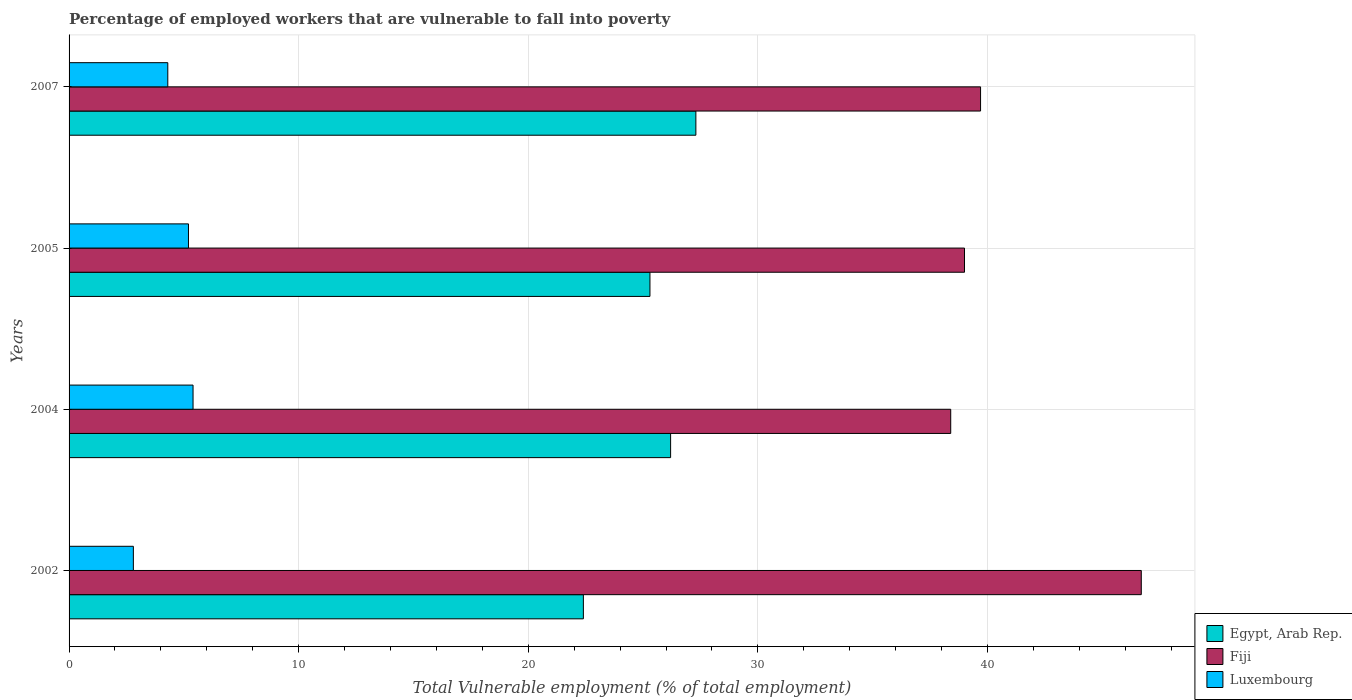How many different coloured bars are there?
Your response must be concise. 3. How many groups of bars are there?
Your answer should be very brief. 4. What is the label of the 2nd group of bars from the top?
Make the answer very short. 2005. In how many cases, is the number of bars for a given year not equal to the number of legend labels?
Ensure brevity in your answer.  0. What is the percentage of employed workers who are vulnerable to fall into poverty in Egypt, Arab Rep. in 2005?
Provide a short and direct response. 25.3. Across all years, what is the maximum percentage of employed workers who are vulnerable to fall into poverty in Fiji?
Offer a very short reply. 46.7. Across all years, what is the minimum percentage of employed workers who are vulnerable to fall into poverty in Luxembourg?
Provide a short and direct response. 2.8. What is the total percentage of employed workers who are vulnerable to fall into poverty in Luxembourg in the graph?
Your response must be concise. 17.7. What is the difference between the percentage of employed workers who are vulnerable to fall into poverty in Egypt, Arab Rep. in 2004 and that in 2005?
Offer a very short reply. 0.9. What is the difference between the percentage of employed workers who are vulnerable to fall into poverty in Egypt, Arab Rep. in 2007 and the percentage of employed workers who are vulnerable to fall into poverty in Luxembourg in 2002?
Your response must be concise. 24.5. What is the average percentage of employed workers who are vulnerable to fall into poverty in Luxembourg per year?
Provide a short and direct response. 4.43. In the year 2004, what is the difference between the percentage of employed workers who are vulnerable to fall into poverty in Egypt, Arab Rep. and percentage of employed workers who are vulnerable to fall into poverty in Luxembourg?
Your answer should be compact. 20.8. In how many years, is the percentage of employed workers who are vulnerable to fall into poverty in Fiji greater than 26 %?
Offer a very short reply. 4. What is the ratio of the percentage of employed workers who are vulnerable to fall into poverty in Fiji in 2002 to that in 2007?
Give a very brief answer. 1.18. Is the difference between the percentage of employed workers who are vulnerable to fall into poverty in Egypt, Arab Rep. in 2002 and 2004 greater than the difference between the percentage of employed workers who are vulnerable to fall into poverty in Luxembourg in 2002 and 2004?
Make the answer very short. No. What is the difference between the highest and the second highest percentage of employed workers who are vulnerable to fall into poverty in Luxembourg?
Your answer should be very brief. 0.2. What is the difference between the highest and the lowest percentage of employed workers who are vulnerable to fall into poverty in Luxembourg?
Offer a terse response. 2.6. In how many years, is the percentage of employed workers who are vulnerable to fall into poverty in Fiji greater than the average percentage of employed workers who are vulnerable to fall into poverty in Fiji taken over all years?
Make the answer very short. 1. What does the 1st bar from the top in 2002 represents?
Your response must be concise. Luxembourg. What does the 1st bar from the bottom in 2004 represents?
Provide a short and direct response. Egypt, Arab Rep. Is it the case that in every year, the sum of the percentage of employed workers who are vulnerable to fall into poverty in Luxembourg and percentage of employed workers who are vulnerable to fall into poverty in Fiji is greater than the percentage of employed workers who are vulnerable to fall into poverty in Egypt, Arab Rep.?
Provide a succinct answer. Yes. Are all the bars in the graph horizontal?
Your response must be concise. Yes. How many years are there in the graph?
Offer a very short reply. 4. What is the difference between two consecutive major ticks on the X-axis?
Offer a very short reply. 10. Does the graph contain grids?
Your response must be concise. Yes. How many legend labels are there?
Ensure brevity in your answer.  3. How are the legend labels stacked?
Make the answer very short. Vertical. What is the title of the graph?
Your response must be concise. Percentage of employed workers that are vulnerable to fall into poverty. What is the label or title of the X-axis?
Offer a terse response. Total Vulnerable employment (% of total employment). What is the Total Vulnerable employment (% of total employment) in Egypt, Arab Rep. in 2002?
Give a very brief answer. 22.4. What is the Total Vulnerable employment (% of total employment) of Fiji in 2002?
Offer a terse response. 46.7. What is the Total Vulnerable employment (% of total employment) of Luxembourg in 2002?
Your response must be concise. 2.8. What is the Total Vulnerable employment (% of total employment) of Egypt, Arab Rep. in 2004?
Keep it short and to the point. 26.2. What is the Total Vulnerable employment (% of total employment) in Fiji in 2004?
Make the answer very short. 38.4. What is the Total Vulnerable employment (% of total employment) of Luxembourg in 2004?
Give a very brief answer. 5.4. What is the Total Vulnerable employment (% of total employment) of Egypt, Arab Rep. in 2005?
Provide a succinct answer. 25.3. What is the Total Vulnerable employment (% of total employment) of Fiji in 2005?
Keep it short and to the point. 39. What is the Total Vulnerable employment (% of total employment) in Luxembourg in 2005?
Your answer should be compact. 5.2. What is the Total Vulnerable employment (% of total employment) of Egypt, Arab Rep. in 2007?
Provide a succinct answer. 27.3. What is the Total Vulnerable employment (% of total employment) of Fiji in 2007?
Keep it short and to the point. 39.7. What is the Total Vulnerable employment (% of total employment) in Luxembourg in 2007?
Ensure brevity in your answer.  4.3. Across all years, what is the maximum Total Vulnerable employment (% of total employment) in Egypt, Arab Rep.?
Give a very brief answer. 27.3. Across all years, what is the maximum Total Vulnerable employment (% of total employment) in Fiji?
Provide a short and direct response. 46.7. Across all years, what is the maximum Total Vulnerable employment (% of total employment) of Luxembourg?
Keep it short and to the point. 5.4. Across all years, what is the minimum Total Vulnerable employment (% of total employment) of Egypt, Arab Rep.?
Offer a terse response. 22.4. Across all years, what is the minimum Total Vulnerable employment (% of total employment) in Fiji?
Your answer should be very brief. 38.4. Across all years, what is the minimum Total Vulnerable employment (% of total employment) of Luxembourg?
Give a very brief answer. 2.8. What is the total Total Vulnerable employment (% of total employment) in Egypt, Arab Rep. in the graph?
Your answer should be very brief. 101.2. What is the total Total Vulnerable employment (% of total employment) in Fiji in the graph?
Your answer should be compact. 163.8. What is the total Total Vulnerable employment (% of total employment) of Luxembourg in the graph?
Keep it short and to the point. 17.7. What is the difference between the Total Vulnerable employment (% of total employment) of Egypt, Arab Rep. in 2002 and that in 2007?
Offer a very short reply. -4.9. What is the difference between the Total Vulnerable employment (% of total employment) of Fiji in 2004 and that in 2005?
Your response must be concise. -0.6. What is the difference between the Total Vulnerable employment (% of total employment) in Luxembourg in 2004 and that in 2005?
Provide a short and direct response. 0.2. What is the difference between the Total Vulnerable employment (% of total employment) in Egypt, Arab Rep. in 2004 and that in 2007?
Keep it short and to the point. -1.1. What is the difference between the Total Vulnerable employment (% of total employment) of Fiji in 2004 and that in 2007?
Your response must be concise. -1.3. What is the difference between the Total Vulnerable employment (% of total employment) of Egypt, Arab Rep. in 2002 and the Total Vulnerable employment (% of total employment) of Luxembourg in 2004?
Offer a very short reply. 17. What is the difference between the Total Vulnerable employment (% of total employment) of Fiji in 2002 and the Total Vulnerable employment (% of total employment) of Luxembourg in 2004?
Make the answer very short. 41.3. What is the difference between the Total Vulnerable employment (% of total employment) in Egypt, Arab Rep. in 2002 and the Total Vulnerable employment (% of total employment) in Fiji in 2005?
Your answer should be very brief. -16.6. What is the difference between the Total Vulnerable employment (% of total employment) of Fiji in 2002 and the Total Vulnerable employment (% of total employment) of Luxembourg in 2005?
Make the answer very short. 41.5. What is the difference between the Total Vulnerable employment (% of total employment) of Egypt, Arab Rep. in 2002 and the Total Vulnerable employment (% of total employment) of Fiji in 2007?
Offer a terse response. -17.3. What is the difference between the Total Vulnerable employment (% of total employment) in Egypt, Arab Rep. in 2002 and the Total Vulnerable employment (% of total employment) in Luxembourg in 2007?
Your response must be concise. 18.1. What is the difference between the Total Vulnerable employment (% of total employment) in Fiji in 2002 and the Total Vulnerable employment (% of total employment) in Luxembourg in 2007?
Your answer should be compact. 42.4. What is the difference between the Total Vulnerable employment (% of total employment) of Fiji in 2004 and the Total Vulnerable employment (% of total employment) of Luxembourg in 2005?
Offer a very short reply. 33.2. What is the difference between the Total Vulnerable employment (% of total employment) in Egypt, Arab Rep. in 2004 and the Total Vulnerable employment (% of total employment) in Fiji in 2007?
Keep it short and to the point. -13.5. What is the difference between the Total Vulnerable employment (% of total employment) in Egypt, Arab Rep. in 2004 and the Total Vulnerable employment (% of total employment) in Luxembourg in 2007?
Give a very brief answer. 21.9. What is the difference between the Total Vulnerable employment (% of total employment) in Fiji in 2004 and the Total Vulnerable employment (% of total employment) in Luxembourg in 2007?
Provide a succinct answer. 34.1. What is the difference between the Total Vulnerable employment (% of total employment) of Egypt, Arab Rep. in 2005 and the Total Vulnerable employment (% of total employment) of Fiji in 2007?
Keep it short and to the point. -14.4. What is the difference between the Total Vulnerable employment (% of total employment) in Egypt, Arab Rep. in 2005 and the Total Vulnerable employment (% of total employment) in Luxembourg in 2007?
Make the answer very short. 21. What is the difference between the Total Vulnerable employment (% of total employment) in Fiji in 2005 and the Total Vulnerable employment (% of total employment) in Luxembourg in 2007?
Your response must be concise. 34.7. What is the average Total Vulnerable employment (% of total employment) in Egypt, Arab Rep. per year?
Your response must be concise. 25.3. What is the average Total Vulnerable employment (% of total employment) in Fiji per year?
Offer a very short reply. 40.95. What is the average Total Vulnerable employment (% of total employment) of Luxembourg per year?
Keep it short and to the point. 4.42. In the year 2002, what is the difference between the Total Vulnerable employment (% of total employment) of Egypt, Arab Rep. and Total Vulnerable employment (% of total employment) of Fiji?
Provide a short and direct response. -24.3. In the year 2002, what is the difference between the Total Vulnerable employment (% of total employment) in Egypt, Arab Rep. and Total Vulnerable employment (% of total employment) in Luxembourg?
Your response must be concise. 19.6. In the year 2002, what is the difference between the Total Vulnerable employment (% of total employment) of Fiji and Total Vulnerable employment (% of total employment) of Luxembourg?
Make the answer very short. 43.9. In the year 2004, what is the difference between the Total Vulnerable employment (% of total employment) of Egypt, Arab Rep. and Total Vulnerable employment (% of total employment) of Luxembourg?
Your response must be concise. 20.8. In the year 2004, what is the difference between the Total Vulnerable employment (% of total employment) of Fiji and Total Vulnerable employment (% of total employment) of Luxembourg?
Make the answer very short. 33. In the year 2005, what is the difference between the Total Vulnerable employment (% of total employment) in Egypt, Arab Rep. and Total Vulnerable employment (% of total employment) in Fiji?
Your answer should be compact. -13.7. In the year 2005, what is the difference between the Total Vulnerable employment (% of total employment) of Egypt, Arab Rep. and Total Vulnerable employment (% of total employment) of Luxembourg?
Offer a very short reply. 20.1. In the year 2005, what is the difference between the Total Vulnerable employment (% of total employment) of Fiji and Total Vulnerable employment (% of total employment) of Luxembourg?
Give a very brief answer. 33.8. In the year 2007, what is the difference between the Total Vulnerable employment (% of total employment) of Egypt, Arab Rep. and Total Vulnerable employment (% of total employment) of Fiji?
Offer a terse response. -12.4. In the year 2007, what is the difference between the Total Vulnerable employment (% of total employment) of Egypt, Arab Rep. and Total Vulnerable employment (% of total employment) of Luxembourg?
Provide a succinct answer. 23. In the year 2007, what is the difference between the Total Vulnerable employment (% of total employment) in Fiji and Total Vulnerable employment (% of total employment) in Luxembourg?
Offer a terse response. 35.4. What is the ratio of the Total Vulnerable employment (% of total employment) of Egypt, Arab Rep. in 2002 to that in 2004?
Your response must be concise. 0.85. What is the ratio of the Total Vulnerable employment (% of total employment) in Fiji in 2002 to that in 2004?
Your answer should be very brief. 1.22. What is the ratio of the Total Vulnerable employment (% of total employment) of Luxembourg in 2002 to that in 2004?
Give a very brief answer. 0.52. What is the ratio of the Total Vulnerable employment (% of total employment) in Egypt, Arab Rep. in 2002 to that in 2005?
Offer a terse response. 0.89. What is the ratio of the Total Vulnerable employment (% of total employment) of Fiji in 2002 to that in 2005?
Give a very brief answer. 1.2. What is the ratio of the Total Vulnerable employment (% of total employment) of Luxembourg in 2002 to that in 2005?
Provide a short and direct response. 0.54. What is the ratio of the Total Vulnerable employment (% of total employment) of Egypt, Arab Rep. in 2002 to that in 2007?
Keep it short and to the point. 0.82. What is the ratio of the Total Vulnerable employment (% of total employment) in Fiji in 2002 to that in 2007?
Provide a succinct answer. 1.18. What is the ratio of the Total Vulnerable employment (% of total employment) of Luxembourg in 2002 to that in 2007?
Offer a terse response. 0.65. What is the ratio of the Total Vulnerable employment (% of total employment) of Egypt, Arab Rep. in 2004 to that in 2005?
Offer a terse response. 1.04. What is the ratio of the Total Vulnerable employment (% of total employment) of Fiji in 2004 to that in 2005?
Offer a very short reply. 0.98. What is the ratio of the Total Vulnerable employment (% of total employment) of Egypt, Arab Rep. in 2004 to that in 2007?
Offer a very short reply. 0.96. What is the ratio of the Total Vulnerable employment (% of total employment) of Fiji in 2004 to that in 2007?
Provide a short and direct response. 0.97. What is the ratio of the Total Vulnerable employment (% of total employment) in Luxembourg in 2004 to that in 2007?
Provide a succinct answer. 1.26. What is the ratio of the Total Vulnerable employment (% of total employment) of Egypt, Arab Rep. in 2005 to that in 2007?
Give a very brief answer. 0.93. What is the ratio of the Total Vulnerable employment (% of total employment) in Fiji in 2005 to that in 2007?
Your response must be concise. 0.98. What is the ratio of the Total Vulnerable employment (% of total employment) in Luxembourg in 2005 to that in 2007?
Your response must be concise. 1.21. What is the difference between the highest and the second highest Total Vulnerable employment (% of total employment) in Egypt, Arab Rep.?
Your answer should be compact. 1.1. What is the difference between the highest and the second highest Total Vulnerable employment (% of total employment) in Luxembourg?
Your answer should be very brief. 0.2. What is the difference between the highest and the lowest Total Vulnerable employment (% of total employment) in Egypt, Arab Rep.?
Your response must be concise. 4.9. 